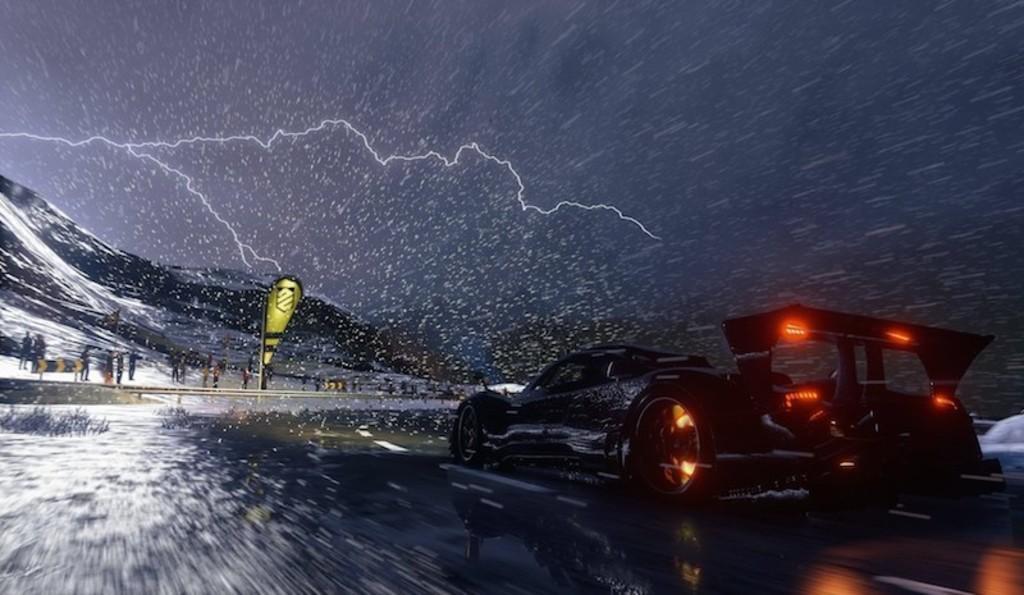Please provide a concise description of this image. This picture is clicked outside. On the right we can see a car running on the road. In the background we can see the sky and we can see the rain and we can see the hills, group of persons, lightning and some other objects. 